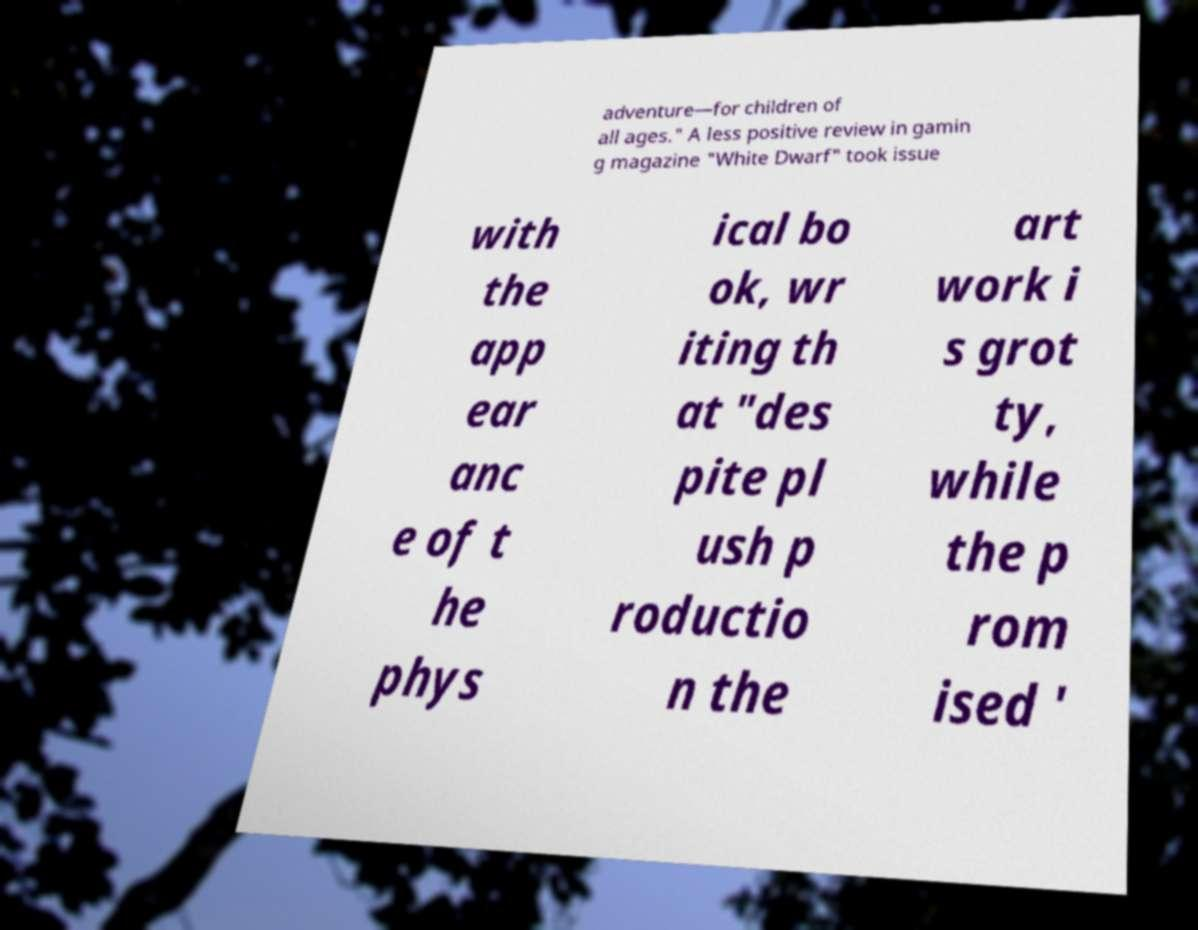Can you read and provide the text displayed in the image?This photo seems to have some interesting text. Can you extract and type it out for me? adventure—for children of all ages." A less positive review in gamin g magazine "White Dwarf" took issue with the app ear anc e of t he phys ical bo ok, wr iting th at "des pite pl ush p roductio n the art work i s grot ty, while the p rom ised ' 